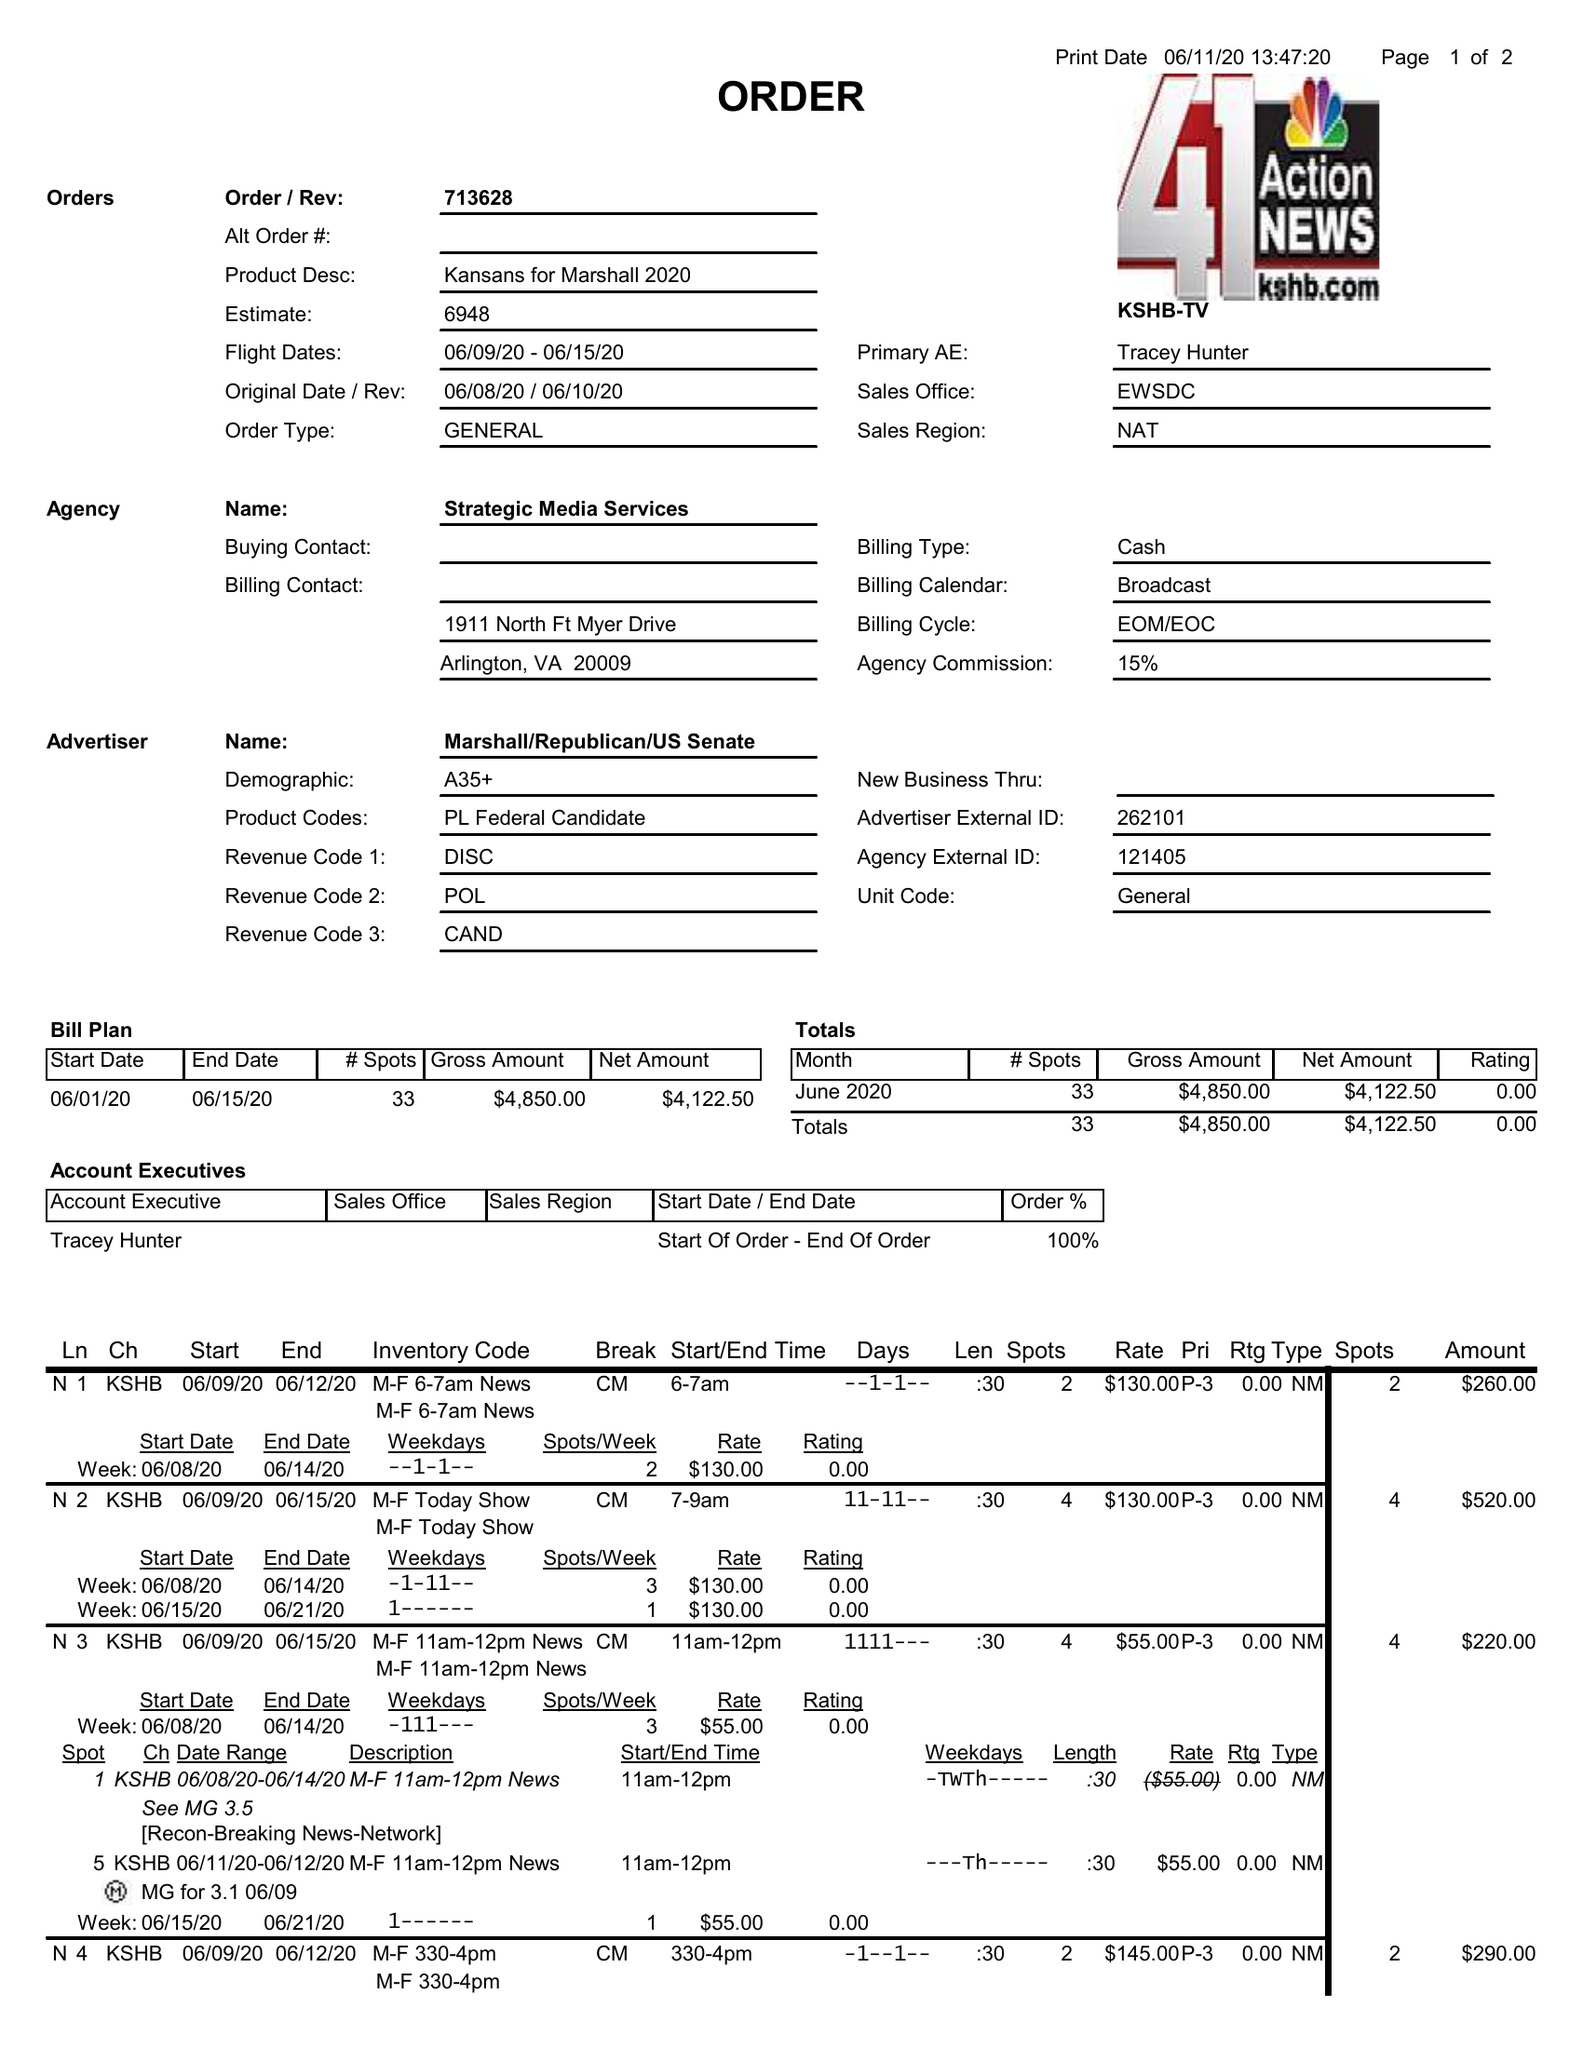What is the value for the contract_num?
Answer the question using a single word or phrase. 713628 